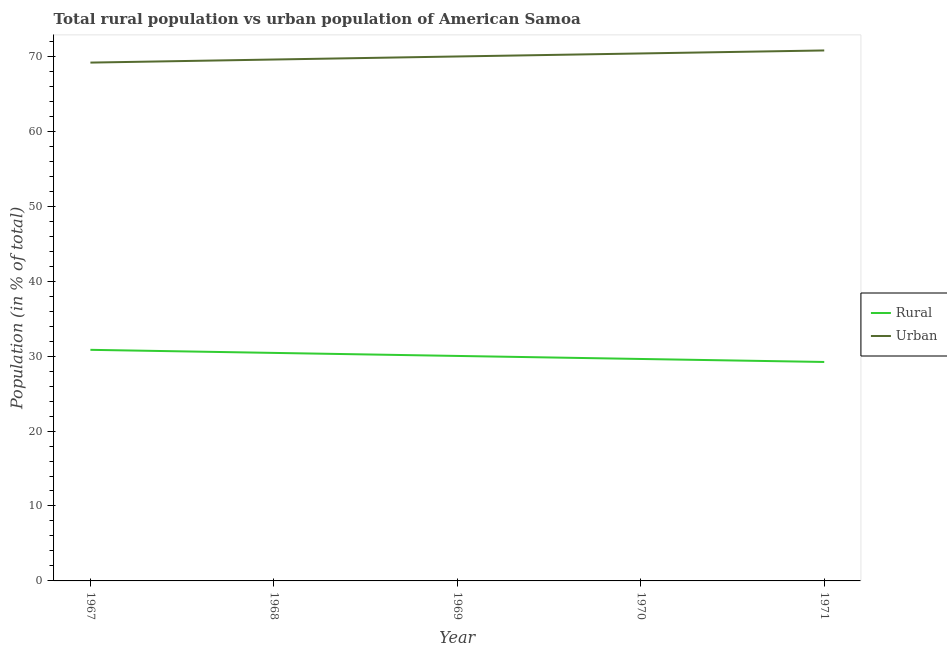Does the line corresponding to urban population intersect with the line corresponding to rural population?
Your answer should be compact. No. What is the rural population in 1971?
Your answer should be very brief. 29.22. Across all years, what is the maximum urban population?
Your answer should be compact. 70.78. Across all years, what is the minimum urban population?
Offer a terse response. 69.16. In which year was the rural population maximum?
Your answer should be compact. 1967. In which year was the rural population minimum?
Your answer should be compact. 1971. What is the total urban population in the graph?
Your answer should be compact. 349.88. What is the difference between the urban population in 1968 and that in 1971?
Your answer should be very brief. -1.21. What is the difference between the rural population in 1969 and the urban population in 1970?
Your response must be concise. -40.36. What is the average urban population per year?
Make the answer very short. 69.98. In the year 1969, what is the difference between the rural population and urban population?
Make the answer very short. -39.96. What is the ratio of the urban population in 1969 to that in 1970?
Offer a terse response. 0.99. Is the urban population in 1967 less than that in 1969?
Make the answer very short. Yes. Is the difference between the rural population in 1967 and 1968 greater than the difference between the urban population in 1967 and 1968?
Your response must be concise. Yes. What is the difference between the highest and the second highest urban population?
Provide a succinct answer. 0.4. What is the difference between the highest and the lowest urban population?
Ensure brevity in your answer.  1.62. Does the rural population monotonically increase over the years?
Keep it short and to the point. No. Is the urban population strictly greater than the rural population over the years?
Ensure brevity in your answer.  Yes. Is the urban population strictly less than the rural population over the years?
Provide a short and direct response. No. How many lines are there?
Make the answer very short. 2. Are the values on the major ticks of Y-axis written in scientific E-notation?
Give a very brief answer. No. Does the graph contain any zero values?
Give a very brief answer. No. Where does the legend appear in the graph?
Your answer should be compact. Center right. How are the legend labels stacked?
Offer a very short reply. Vertical. What is the title of the graph?
Give a very brief answer. Total rural population vs urban population of American Samoa. What is the label or title of the X-axis?
Make the answer very short. Year. What is the label or title of the Y-axis?
Provide a short and direct response. Population (in % of total). What is the Population (in % of total) in Rural in 1967?
Ensure brevity in your answer.  30.84. What is the Population (in % of total) in Urban in 1967?
Make the answer very short. 69.16. What is the Population (in % of total) of Rural in 1968?
Offer a very short reply. 30.43. What is the Population (in % of total) in Urban in 1968?
Provide a short and direct response. 69.57. What is the Population (in % of total) in Rural in 1969?
Offer a very short reply. 30.02. What is the Population (in % of total) in Urban in 1969?
Give a very brief answer. 69.98. What is the Population (in % of total) of Rural in 1970?
Your answer should be compact. 29.62. What is the Population (in % of total) in Urban in 1970?
Your answer should be very brief. 70.38. What is the Population (in % of total) of Rural in 1971?
Offer a very short reply. 29.22. What is the Population (in % of total) in Urban in 1971?
Give a very brief answer. 70.78. Across all years, what is the maximum Population (in % of total) in Rural?
Give a very brief answer. 30.84. Across all years, what is the maximum Population (in % of total) in Urban?
Your answer should be very brief. 70.78. Across all years, what is the minimum Population (in % of total) in Rural?
Offer a terse response. 29.22. Across all years, what is the minimum Population (in % of total) of Urban?
Your response must be concise. 69.16. What is the total Population (in % of total) in Rural in the graph?
Your response must be concise. 150.12. What is the total Population (in % of total) in Urban in the graph?
Make the answer very short. 349.88. What is the difference between the Population (in % of total) of Rural in 1967 and that in 1968?
Give a very brief answer. 0.41. What is the difference between the Population (in % of total) in Urban in 1967 and that in 1968?
Provide a short and direct response. -0.41. What is the difference between the Population (in % of total) in Rural in 1967 and that in 1969?
Offer a very short reply. 0.82. What is the difference between the Population (in % of total) of Urban in 1967 and that in 1969?
Your answer should be very brief. -0.82. What is the difference between the Population (in % of total) of Rural in 1967 and that in 1970?
Provide a succinct answer. 1.22. What is the difference between the Population (in % of total) of Urban in 1967 and that in 1970?
Make the answer very short. -1.22. What is the difference between the Population (in % of total) of Rural in 1967 and that in 1971?
Give a very brief answer. 1.62. What is the difference between the Population (in % of total) of Urban in 1967 and that in 1971?
Your answer should be compact. -1.62. What is the difference between the Population (in % of total) of Rural in 1968 and that in 1969?
Your answer should be compact. 0.41. What is the difference between the Population (in % of total) of Urban in 1968 and that in 1969?
Make the answer very short. -0.41. What is the difference between the Population (in % of total) of Rural in 1968 and that in 1970?
Provide a succinct answer. 0.81. What is the difference between the Population (in % of total) of Urban in 1968 and that in 1970?
Provide a short and direct response. -0.81. What is the difference between the Population (in % of total) in Rural in 1968 and that in 1971?
Your response must be concise. 1.21. What is the difference between the Population (in % of total) of Urban in 1968 and that in 1971?
Ensure brevity in your answer.  -1.21. What is the difference between the Population (in % of total) in Rural in 1969 and that in 1970?
Provide a short and direct response. 0.4. What is the difference between the Population (in % of total) of Urban in 1969 and that in 1970?
Your answer should be very brief. -0.4. What is the difference between the Population (in % of total) in Rural in 1969 and that in 1971?
Keep it short and to the point. 0.8. What is the difference between the Population (in % of total) in Urban in 1969 and that in 1971?
Provide a short and direct response. -0.8. What is the difference between the Population (in % of total) in Rural in 1970 and that in 1971?
Ensure brevity in your answer.  0.4. What is the difference between the Population (in % of total) of Rural in 1967 and the Population (in % of total) of Urban in 1968?
Provide a short and direct response. -38.74. What is the difference between the Population (in % of total) in Rural in 1967 and the Population (in % of total) in Urban in 1969?
Ensure brevity in your answer.  -39.14. What is the difference between the Population (in % of total) in Rural in 1967 and the Population (in % of total) in Urban in 1970?
Keep it short and to the point. -39.55. What is the difference between the Population (in % of total) of Rural in 1967 and the Population (in % of total) of Urban in 1971?
Ensure brevity in your answer.  -39.95. What is the difference between the Population (in % of total) in Rural in 1968 and the Population (in % of total) in Urban in 1969?
Your answer should be compact. -39.55. What is the difference between the Population (in % of total) of Rural in 1968 and the Population (in % of total) of Urban in 1970?
Your response must be concise. -39.96. What is the difference between the Population (in % of total) of Rural in 1968 and the Population (in % of total) of Urban in 1971?
Ensure brevity in your answer.  -40.36. What is the difference between the Population (in % of total) of Rural in 1969 and the Population (in % of total) of Urban in 1970?
Give a very brief answer. -40.36. What is the difference between the Population (in % of total) of Rural in 1969 and the Population (in % of total) of Urban in 1971?
Your answer should be compact. -40.76. What is the difference between the Population (in % of total) in Rural in 1970 and the Population (in % of total) in Urban in 1971?
Your answer should be compact. -41.17. What is the average Population (in % of total) of Rural per year?
Provide a succinct answer. 30.02. What is the average Population (in % of total) in Urban per year?
Provide a succinct answer. 69.98. In the year 1967, what is the difference between the Population (in % of total) of Rural and Population (in % of total) of Urban?
Your answer should be compact. -38.33. In the year 1968, what is the difference between the Population (in % of total) in Rural and Population (in % of total) in Urban?
Your answer should be compact. -39.15. In the year 1969, what is the difference between the Population (in % of total) in Rural and Population (in % of total) in Urban?
Keep it short and to the point. -39.96. In the year 1970, what is the difference between the Population (in % of total) in Rural and Population (in % of total) in Urban?
Offer a very short reply. -40.77. In the year 1971, what is the difference between the Population (in % of total) of Rural and Population (in % of total) of Urban?
Provide a short and direct response. -41.57. What is the ratio of the Population (in % of total) of Rural in 1967 to that in 1968?
Your response must be concise. 1.01. What is the ratio of the Population (in % of total) of Rural in 1967 to that in 1969?
Offer a terse response. 1.03. What is the ratio of the Population (in % of total) of Urban in 1967 to that in 1969?
Ensure brevity in your answer.  0.99. What is the ratio of the Population (in % of total) of Rural in 1967 to that in 1970?
Keep it short and to the point. 1.04. What is the ratio of the Population (in % of total) of Urban in 1967 to that in 1970?
Your response must be concise. 0.98. What is the ratio of the Population (in % of total) of Rural in 1967 to that in 1971?
Ensure brevity in your answer.  1.06. What is the ratio of the Population (in % of total) of Urban in 1967 to that in 1971?
Give a very brief answer. 0.98. What is the ratio of the Population (in % of total) of Rural in 1968 to that in 1969?
Your answer should be very brief. 1.01. What is the ratio of the Population (in % of total) in Rural in 1968 to that in 1970?
Give a very brief answer. 1.03. What is the ratio of the Population (in % of total) in Rural in 1968 to that in 1971?
Provide a short and direct response. 1.04. What is the ratio of the Population (in % of total) in Urban in 1968 to that in 1971?
Give a very brief answer. 0.98. What is the ratio of the Population (in % of total) of Rural in 1969 to that in 1970?
Your response must be concise. 1.01. What is the ratio of the Population (in % of total) in Rural in 1969 to that in 1971?
Keep it short and to the point. 1.03. What is the ratio of the Population (in % of total) in Rural in 1970 to that in 1971?
Offer a terse response. 1.01. What is the ratio of the Population (in % of total) in Urban in 1970 to that in 1971?
Your answer should be very brief. 0.99. What is the difference between the highest and the second highest Population (in % of total) in Rural?
Make the answer very short. 0.41. What is the difference between the highest and the second highest Population (in % of total) in Urban?
Keep it short and to the point. 0.4. What is the difference between the highest and the lowest Population (in % of total) of Rural?
Ensure brevity in your answer.  1.62. What is the difference between the highest and the lowest Population (in % of total) in Urban?
Give a very brief answer. 1.62. 